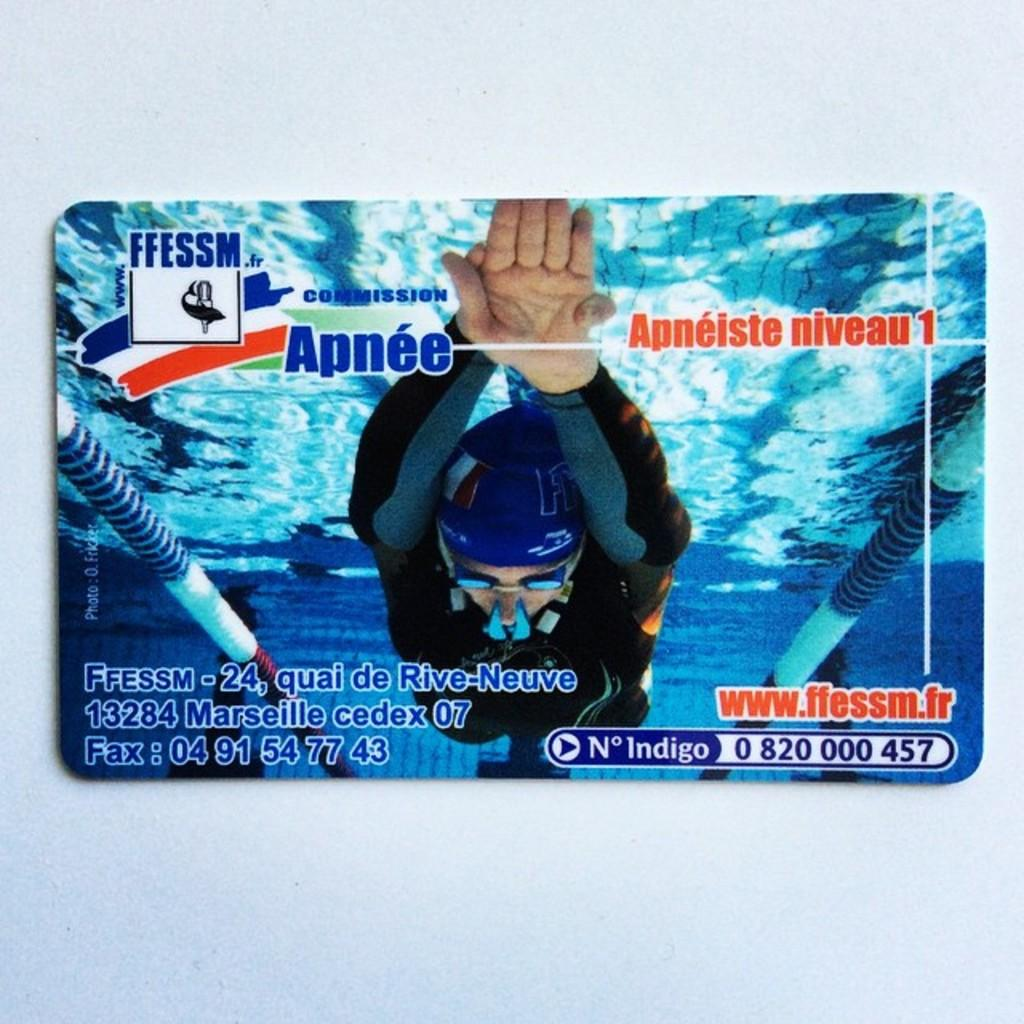What is the main subject of the card in the image? The card depicts a person in a swimming pool. What can be found at the bottom of the card? There is text at the bottom of the card. What color is the wall in the background of the image? The wall in the background of the image is white. What type of bone is visible in the image? There is no bone present in the image; it features a person in a swimming pool on a card. What invention is being used by the person in the swimming pool? The image does not show any specific invention being used by the person in the swimming pool. 